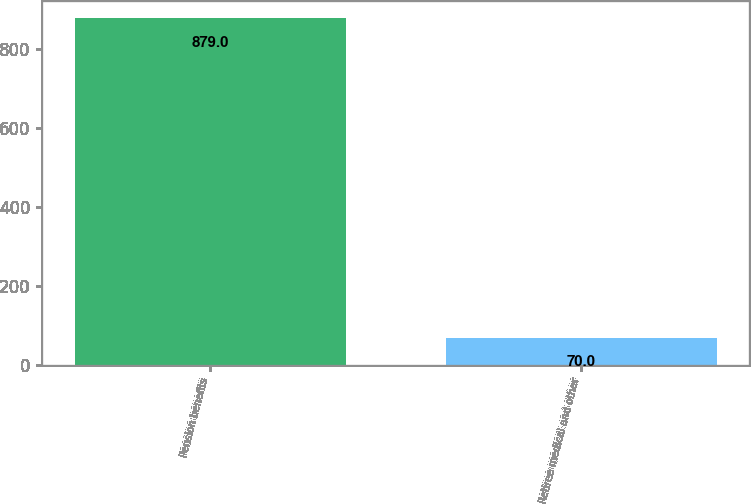Convert chart to OTSL. <chart><loc_0><loc_0><loc_500><loc_500><bar_chart><fcel>Pension benefits<fcel>Retiree medical and other<nl><fcel>879<fcel>70<nl></chart> 